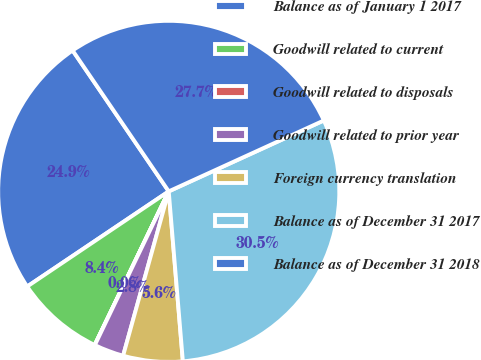Convert chart to OTSL. <chart><loc_0><loc_0><loc_500><loc_500><pie_chart><fcel>Balance as of January 1 2017<fcel>Goodwill related to current<fcel>Goodwill related to disposals<fcel>Goodwill related to prior year<fcel>Foreign currency translation<fcel>Balance as of December 31 2017<fcel>Balance as of December 31 2018<nl><fcel>24.89%<fcel>8.43%<fcel>0.02%<fcel>2.82%<fcel>5.63%<fcel>30.5%<fcel>27.7%<nl></chart> 